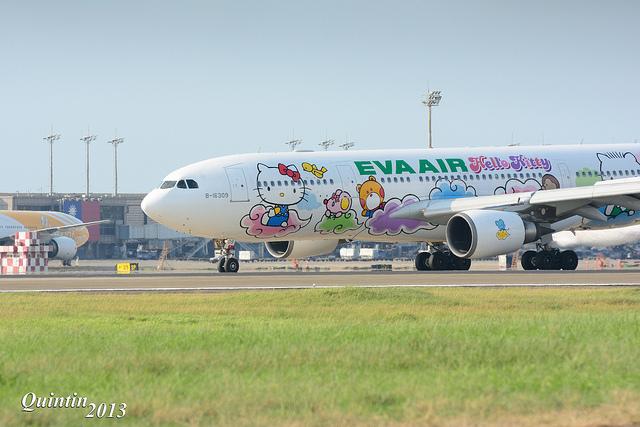What type of airplane is this?
Quick response, please. Eva air. Is that a commercial airplane?
Give a very brief answer. Yes. What fictional character is first in line on this airplane?
Short answer required. Hello kitty. Is the plane taking off?
Concise answer only. No. 